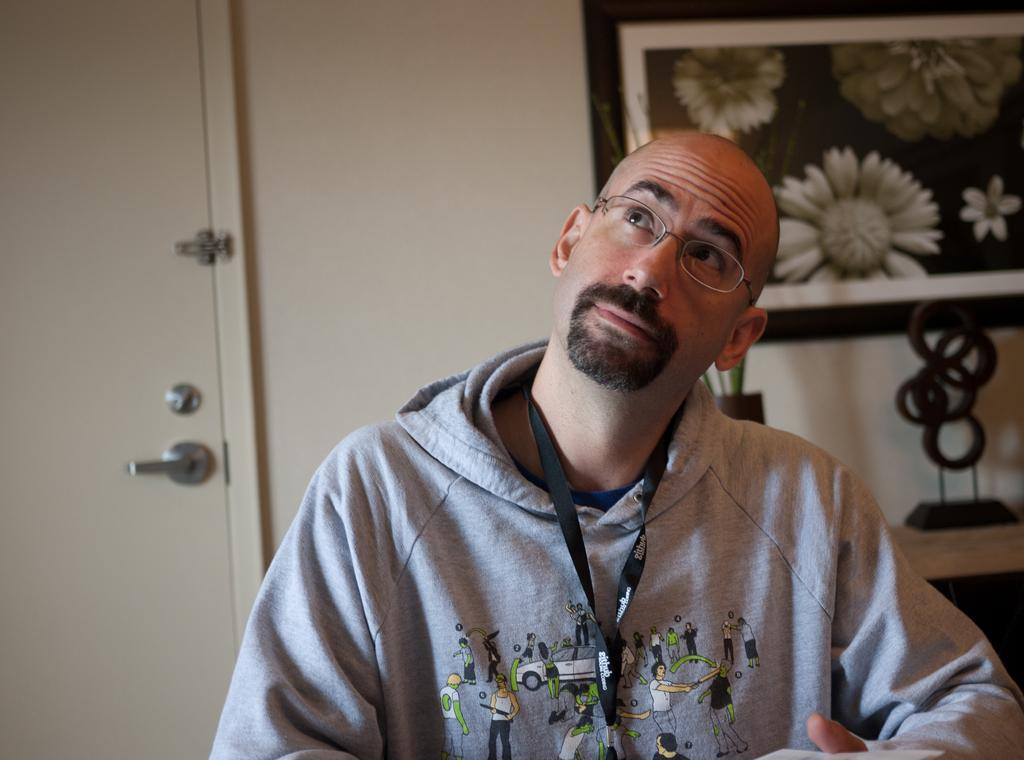What is present in the image? There is a person in the image. Can you describe the person's appearance? The person is wearing a tag. What is visible behind the person? There is a wall behind the person. Are there any openings in the wall? Yes, there is a door in the wall. What decorations can be seen on the wall? There are photo frames on the wall. What else can be seen on the wall or nearby? There are objects on a shelf. How many rabbits are sitting on the person's lap in the image? There are no rabbits present in the image. What color is the kitty that is playing with the person's tag? There is no kitty present in the image. 